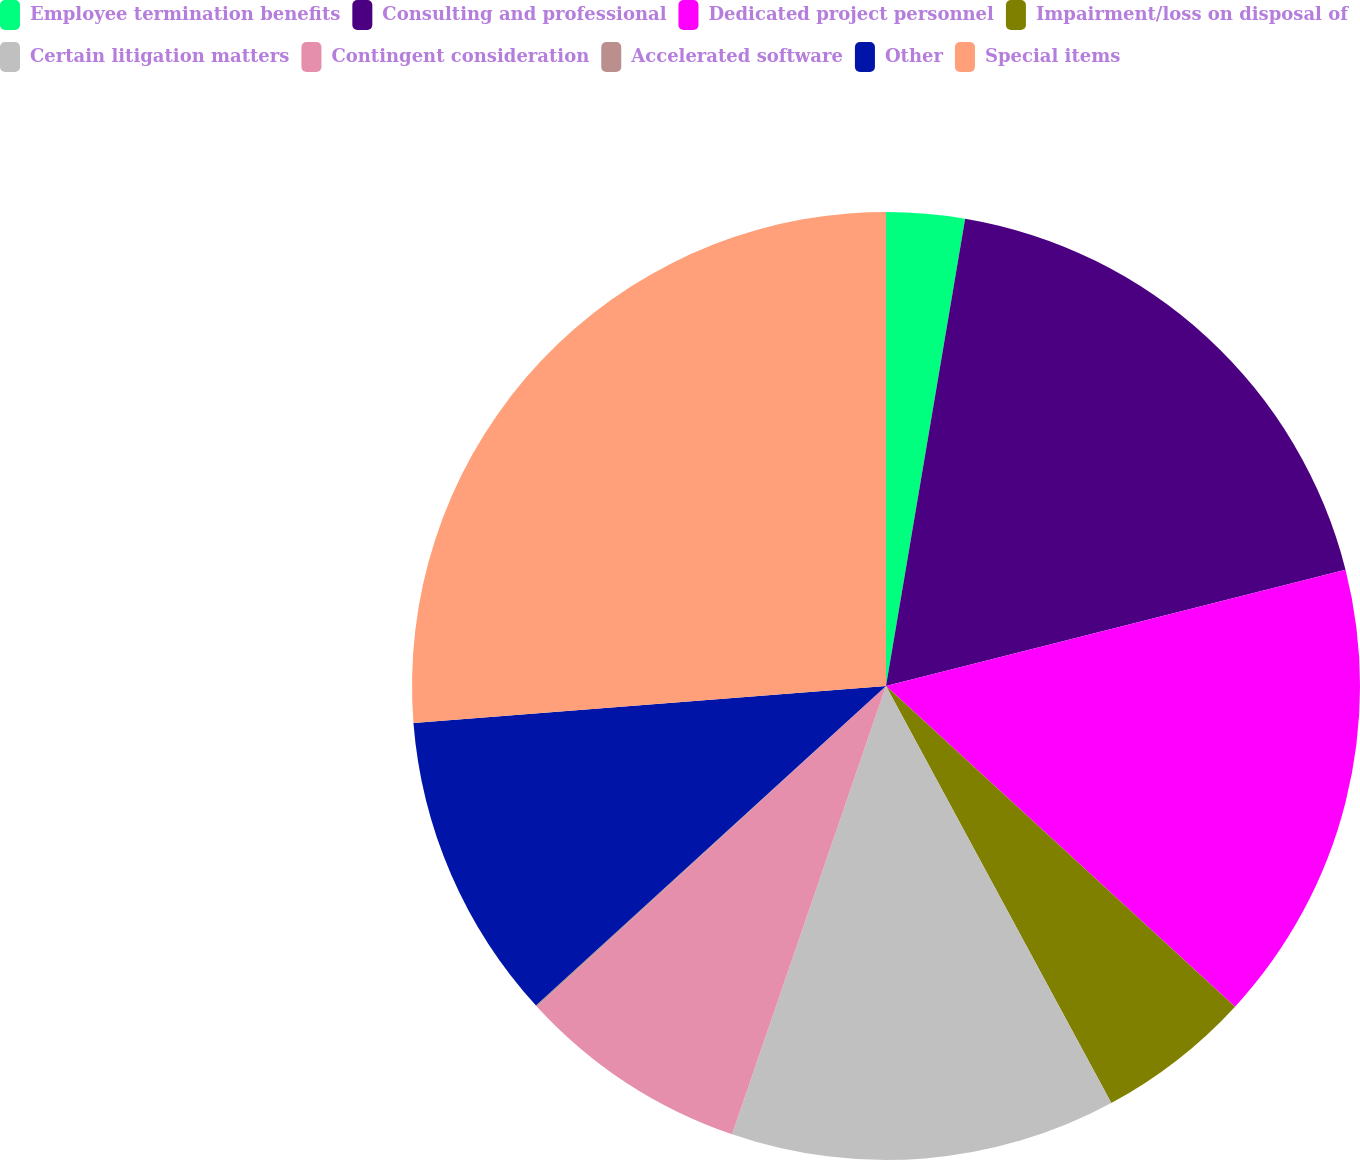Convert chart. <chart><loc_0><loc_0><loc_500><loc_500><pie_chart><fcel>Employee termination benefits<fcel>Consulting and professional<fcel>Dedicated project personnel<fcel>Impairment/loss on disposal of<fcel>Certain litigation matters<fcel>Contingent consideration<fcel>Accelerated software<fcel>Other<fcel>Special items<nl><fcel>2.67%<fcel>18.39%<fcel>15.77%<fcel>5.29%<fcel>13.15%<fcel>7.91%<fcel>0.05%<fcel>10.53%<fcel>26.25%<nl></chart> 